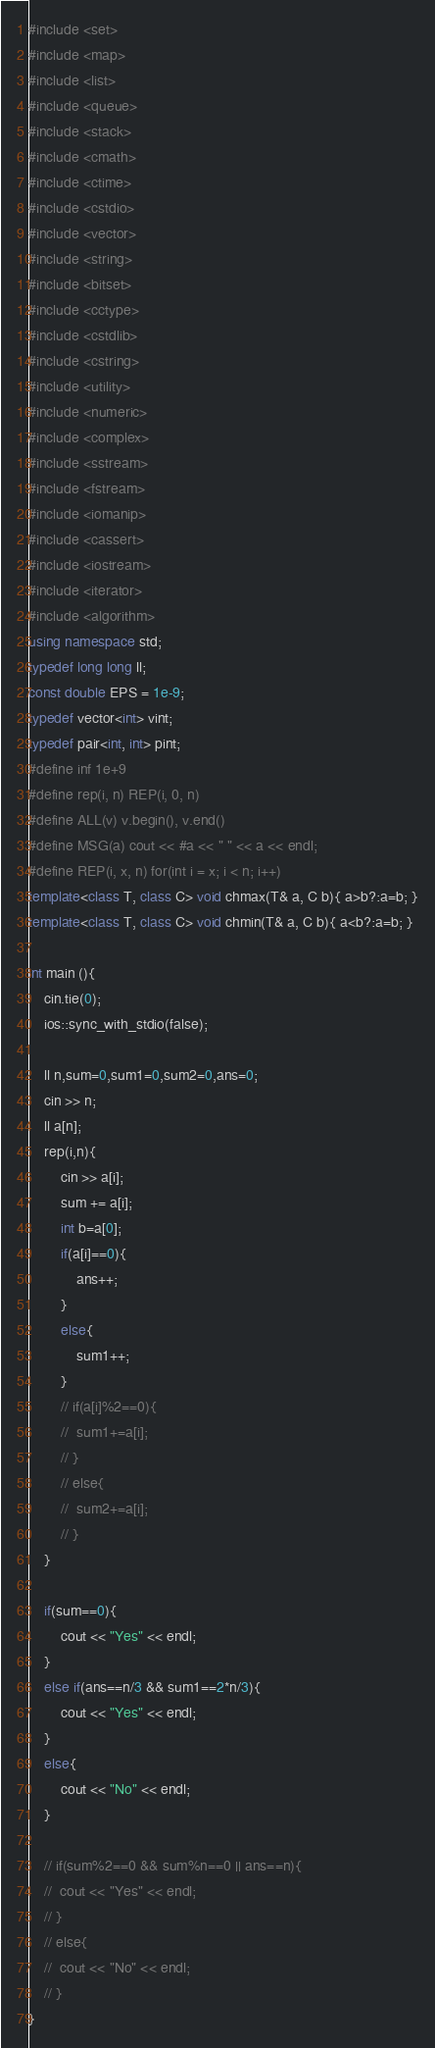<code> <loc_0><loc_0><loc_500><loc_500><_C++_>#include <set>
#include <map>
#include <list>
#include <queue>
#include <stack>
#include <cmath>
#include <ctime>
#include <cstdio>
#include <vector>
#include <string>
#include <bitset>
#include <cctype>
#include <cstdlib>
#include <cstring>
#include <utility>
#include <numeric>
#include <complex>
#include <sstream>
#include <fstream>
#include <iomanip>
#include <cassert>
#include <iostream>
#include <iterator>
#include <algorithm>
using namespace std;
typedef long long ll;
const double EPS = 1e-9;
typedef vector<int> vint;
typedef pair<int, int> pint;
#define inf 1e+9
#define rep(i, n) REP(i, 0, n)
#define ALL(v) v.begin(), v.end()
#define MSG(a) cout << #a << " " << a << endl;
#define REP(i, x, n) for(int i = x; i < n; i++)
template<class T, class C> void chmax(T& a, C b){ a>b?:a=b; }
template<class T, class C> void chmin(T& a, C b){ a<b?:a=b; }

int main (){
	cin.tie(0);
   	ios::sync_with_stdio(false);

    ll n,sum=0,sum1=0,sum2=0,ans=0;
	cin >> n;
	ll a[n];
	rep(i,n){
		cin >> a[i];
		sum += a[i];
		int b=a[0];
		if(a[i]==0){
			ans++;
		}
		else{
			sum1++;
		}
		// if(a[i]%2==0){
		// 	sum1+=a[i];
		// }
		// else{ 
		// 	sum2+=a[i];
		// }
	}

	if(sum==0){
		cout << "Yes" << endl;
	}
	else if(ans==n/3 && sum1==2*n/3){
		cout << "Yes" << endl;
	}
	else{
		cout << "No" << endl;
	}

	// if(sum%2==0 && sum%n==0 || ans==n){
	// 	cout << "Yes" << endl;
	// }
	// else{
	// 	cout << "No" << endl;
	// }	
}</code> 